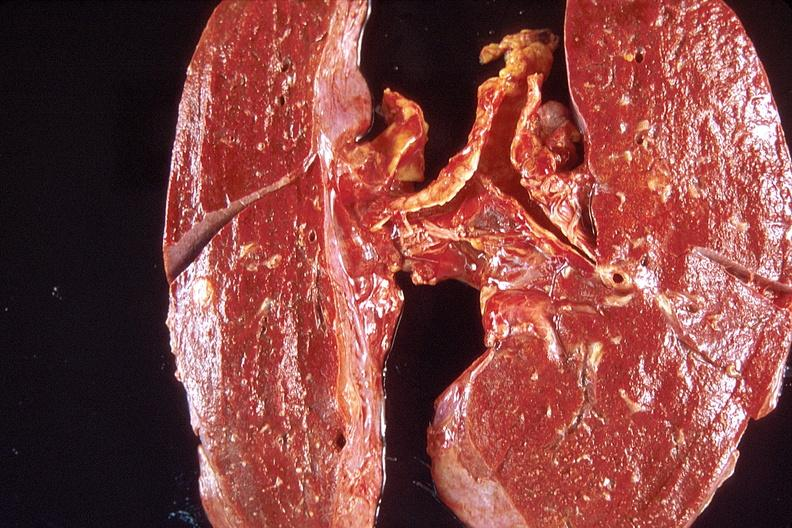s respiratory present?
Answer the question using a single word or phrase. Yes 